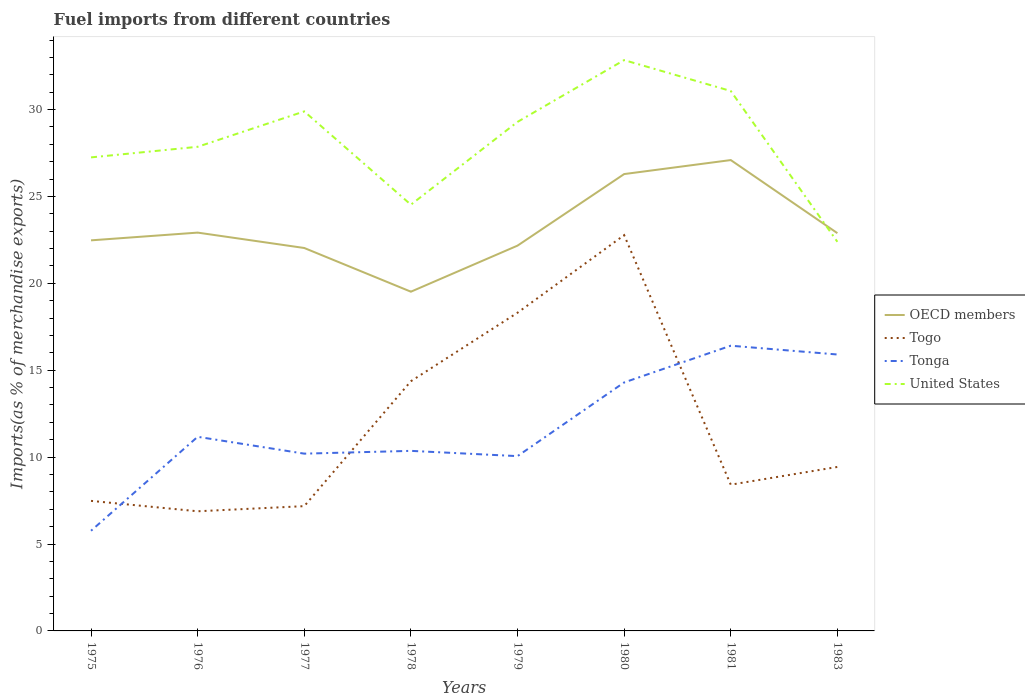How many different coloured lines are there?
Your answer should be very brief. 4. Is the number of lines equal to the number of legend labels?
Provide a succinct answer. Yes. Across all years, what is the maximum percentage of imports to different countries in Tonga?
Keep it short and to the point. 5.76. In which year was the percentage of imports to different countries in Togo maximum?
Make the answer very short. 1976. What is the total percentage of imports to different countries in OECD members in the graph?
Your answer should be compact. -4.25. What is the difference between the highest and the second highest percentage of imports to different countries in Tonga?
Ensure brevity in your answer.  10.65. What is the difference between the highest and the lowest percentage of imports to different countries in OECD members?
Your response must be concise. 2. Does the graph contain grids?
Your response must be concise. No. Where does the legend appear in the graph?
Ensure brevity in your answer.  Center right. How many legend labels are there?
Provide a short and direct response. 4. What is the title of the graph?
Your response must be concise. Fuel imports from different countries. Does "Albania" appear as one of the legend labels in the graph?
Give a very brief answer. No. What is the label or title of the Y-axis?
Keep it short and to the point. Imports(as % of merchandise exports). What is the Imports(as % of merchandise exports) of OECD members in 1975?
Your answer should be compact. 22.47. What is the Imports(as % of merchandise exports) of Togo in 1975?
Ensure brevity in your answer.  7.48. What is the Imports(as % of merchandise exports) of Tonga in 1975?
Your answer should be compact. 5.76. What is the Imports(as % of merchandise exports) of United States in 1975?
Keep it short and to the point. 27.25. What is the Imports(as % of merchandise exports) of OECD members in 1976?
Provide a short and direct response. 22.92. What is the Imports(as % of merchandise exports) in Togo in 1976?
Your answer should be compact. 6.88. What is the Imports(as % of merchandise exports) of Tonga in 1976?
Your answer should be compact. 11.17. What is the Imports(as % of merchandise exports) of United States in 1976?
Keep it short and to the point. 27.86. What is the Imports(as % of merchandise exports) of OECD members in 1977?
Offer a very short reply. 22.03. What is the Imports(as % of merchandise exports) in Togo in 1977?
Offer a terse response. 7.18. What is the Imports(as % of merchandise exports) of Tonga in 1977?
Ensure brevity in your answer.  10.2. What is the Imports(as % of merchandise exports) in United States in 1977?
Your response must be concise. 29.89. What is the Imports(as % of merchandise exports) in OECD members in 1978?
Your response must be concise. 19.52. What is the Imports(as % of merchandise exports) in Togo in 1978?
Provide a succinct answer. 14.37. What is the Imports(as % of merchandise exports) in Tonga in 1978?
Give a very brief answer. 10.36. What is the Imports(as % of merchandise exports) of United States in 1978?
Give a very brief answer. 24.53. What is the Imports(as % of merchandise exports) in OECD members in 1979?
Provide a short and direct response. 22.17. What is the Imports(as % of merchandise exports) in Togo in 1979?
Keep it short and to the point. 18.31. What is the Imports(as % of merchandise exports) of Tonga in 1979?
Your response must be concise. 10.06. What is the Imports(as % of merchandise exports) in United States in 1979?
Your answer should be very brief. 29.29. What is the Imports(as % of merchandise exports) of OECD members in 1980?
Make the answer very short. 26.29. What is the Imports(as % of merchandise exports) in Togo in 1980?
Offer a terse response. 22.77. What is the Imports(as % of merchandise exports) of Tonga in 1980?
Ensure brevity in your answer.  14.3. What is the Imports(as % of merchandise exports) of United States in 1980?
Ensure brevity in your answer.  32.84. What is the Imports(as % of merchandise exports) of OECD members in 1981?
Ensure brevity in your answer.  27.09. What is the Imports(as % of merchandise exports) in Togo in 1981?
Ensure brevity in your answer.  8.41. What is the Imports(as % of merchandise exports) in Tonga in 1981?
Keep it short and to the point. 16.41. What is the Imports(as % of merchandise exports) in United States in 1981?
Offer a terse response. 31.07. What is the Imports(as % of merchandise exports) in OECD members in 1983?
Ensure brevity in your answer.  22.89. What is the Imports(as % of merchandise exports) in Togo in 1983?
Give a very brief answer. 9.44. What is the Imports(as % of merchandise exports) of Tonga in 1983?
Make the answer very short. 15.91. What is the Imports(as % of merchandise exports) in United States in 1983?
Give a very brief answer. 22.39. Across all years, what is the maximum Imports(as % of merchandise exports) of OECD members?
Your answer should be compact. 27.09. Across all years, what is the maximum Imports(as % of merchandise exports) of Togo?
Provide a succinct answer. 22.77. Across all years, what is the maximum Imports(as % of merchandise exports) in Tonga?
Make the answer very short. 16.41. Across all years, what is the maximum Imports(as % of merchandise exports) of United States?
Your answer should be compact. 32.84. Across all years, what is the minimum Imports(as % of merchandise exports) in OECD members?
Keep it short and to the point. 19.52. Across all years, what is the minimum Imports(as % of merchandise exports) in Togo?
Ensure brevity in your answer.  6.88. Across all years, what is the minimum Imports(as % of merchandise exports) of Tonga?
Offer a very short reply. 5.76. Across all years, what is the minimum Imports(as % of merchandise exports) in United States?
Give a very brief answer. 22.39. What is the total Imports(as % of merchandise exports) of OECD members in the graph?
Provide a succinct answer. 185.38. What is the total Imports(as % of merchandise exports) in Togo in the graph?
Your answer should be compact. 94.85. What is the total Imports(as % of merchandise exports) in Tonga in the graph?
Give a very brief answer. 94.17. What is the total Imports(as % of merchandise exports) of United States in the graph?
Provide a short and direct response. 225.12. What is the difference between the Imports(as % of merchandise exports) in OECD members in 1975 and that in 1976?
Provide a short and direct response. -0.44. What is the difference between the Imports(as % of merchandise exports) in Togo in 1975 and that in 1976?
Your answer should be compact. 0.6. What is the difference between the Imports(as % of merchandise exports) of Tonga in 1975 and that in 1976?
Your response must be concise. -5.41. What is the difference between the Imports(as % of merchandise exports) of United States in 1975 and that in 1976?
Offer a very short reply. -0.61. What is the difference between the Imports(as % of merchandise exports) of OECD members in 1975 and that in 1977?
Provide a short and direct response. 0.44. What is the difference between the Imports(as % of merchandise exports) in Togo in 1975 and that in 1977?
Provide a short and direct response. 0.3. What is the difference between the Imports(as % of merchandise exports) in Tonga in 1975 and that in 1977?
Make the answer very short. -4.44. What is the difference between the Imports(as % of merchandise exports) in United States in 1975 and that in 1977?
Your answer should be compact. -2.65. What is the difference between the Imports(as % of merchandise exports) in OECD members in 1975 and that in 1978?
Provide a short and direct response. 2.96. What is the difference between the Imports(as % of merchandise exports) in Togo in 1975 and that in 1978?
Keep it short and to the point. -6.89. What is the difference between the Imports(as % of merchandise exports) in Tonga in 1975 and that in 1978?
Make the answer very short. -4.6. What is the difference between the Imports(as % of merchandise exports) in United States in 1975 and that in 1978?
Your answer should be very brief. 2.72. What is the difference between the Imports(as % of merchandise exports) of OECD members in 1975 and that in 1979?
Provide a succinct answer. 0.3. What is the difference between the Imports(as % of merchandise exports) in Togo in 1975 and that in 1979?
Your response must be concise. -10.83. What is the difference between the Imports(as % of merchandise exports) in Tonga in 1975 and that in 1979?
Offer a terse response. -4.29. What is the difference between the Imports(as % of merchandise exports) in United States in 1975 and that in 1979?
Your answer should be very brief. -2.04. What is the difference between the Imports(as % of merchandise exports) of OECD members in 1975 and that in 1980?
Ensure brevity in your answer.  -3.81. What is the difference between the Imports(as % of merchandise exports) of Togo in 1975 and that in 1980?
Your response must be concise. -15.29. What is the difference between the Imports(as % of merchandise exports) of Tonga in 1975 and that in 1980?
Your answer should be very brief. -8.53. What is the difference between the Imports(as % of merchandise exports) in United States in 1975 and that in 1980?
Offer a terse response. -5.6. What is the difference between the Imports(as % of merchandise exports) of OECD members in 1975 and that in 1981?
Offer a very short reply. -4.62. What is the difference between the Imports(as % of merchandise exports) of Togo in 1975 and that in 1981?
Provide a short and direct response. -0.93. What is the difference between the Imports(as % of merchandise exports) of Tonga in 1975 and that in 1981?
Keep it short and to the point. -10.65. What is the difference between the Imports(as % of merchandise exports) of United States in 1975 and that in 1981?
Ensure brevity in your answer.  -3.82. What is the difference between the Imports(as % of merchandise exports) of OECD members in 1975 and that in 1983?
Give a very brief answer. -0.41. What is the difference between the Imports(as % of merchandise exports) in Togo in 1975 and that in 1983?
Your answer should be compact. -1.95. What is the difference between the Imports(as % of merchandise exports) of Tonga in 1975 and that in 1983?
Keep it short and to the point. -10.14. What is the difference between the Imports(as % of merchandise exports) in United States in 1975 and that in 1983?
Offer a very short reply. 4.86. What is the difference between the Imports(as % of merchandise exports) in OECD members in 1976 and that in 1977?
Provide a succinct answer. 0.89. What is the difference between the Imports(as % of merchandise exports) in Togo in 1976 and that in 1977?
Give a very brief answer. -0.3. What is the difference between the Imports(as % of merchandise exports) of Tonga in 1976 and that in 1977?
Your answer should be compact. 0.97. What is the difference between the Imports(as % of merchandise exports) of United States in 1976 and that in 1977?
Your response must be concise. -2.04. What is the difference between the Imports(as % of merchandise exports) of OECD members in 1976 and that in 1978?
Your response must be concise. 3.4. What is the difference between the Imports(as % of merchandise exports) of Togo in 1976 and that in 1978?
Offer a very short reply. -7.48. What is the difference between the Imports(as % of merchandise exports) of Tonga in 1976 and that in 1978?
Provide a succinct answer. 0.81. What is the difference between the Imports(as % of merchandise exports) of United States in 1976 and that in 1978?
Your answer should be compact. 3.33. What is the difference between the Imports(as % of merchandise exports) of OECD members in 1976 and that in 1979?
Offer a very short reply. 0.75. What is the difference between the Imports(as % of merchandise exports) in Togo in 1976 and that in 1979?
Offer a very short reply. -11.42. What is the difference between the Imports(as % of merchandise exports) in Tonga in 1976 and that in 1979?
Your answer should be very brief. 1.11. What is the difference between the Imports(as % of merchandise exports) of United States in 1976 and that in 1979?
Your answer should be compact. -1.43. What is the difference between the Imports(as % of merchandise exports) in OECD members in 1976 and that in 1980?
Give a very brief answer. -3.37. What is the difference between the Imports(as % of merchandise exports) of Togo in 1976 and that in 1980?
Make the answer very short. -15.89. What is the difference between the Imports(as % of merchandise exports) in Tonga in 1976 and that in 1980?
Provide a short and direct response. -3.13. What is the difference between the Imports(as % of merchandise exports) of United States in 1976 and that in 1980?
Your answer should be very brief. -4.99. What is the difference between the Imports(as % of merchandise exports) in OECD members in 1976 and that in 1981?
Ensure brevity in your answer.  -4.17. What is the difference between the Imports(as % of merchandise exports) in Togo in 1976 and that in 1981?
Provide a succinct answer. -1.53. What is the difference between the Imports(as % of merchandise exports) in Tonga in 1976 and that in 1981?
Ensure brevity in your answer.  -5.24. What is the difference between the Imports(as % of merchandise exports) in United States in 1976 and that in 1981?
Provide a succinct answer. -3.21. What is the difference between the Imports(as % of merchandise exports) of OECD members in 1976 and that in 1983?
Provide a short and direct response. 0.03. What is the difference between the Imports(as % of merchandise exports) of Togo in 1976 and that in 1983?
Offer a terse response. -2.55. What is the difference between the Imports(as % of merchandise exports) of Tonga in 1976 and that in 1983?
Your answer should be very brief. -4.74. What is the difference between the Imports(as % of merchandise exports) of United States in 1976 and that in 1983?
Your answer should be compact. 5.47. What is the difference between the Imports(as % of merchandise exports) in OECD members in 1977 and that in 1978?
Give a very brief answer. 2.51. What is the difference between the Imports(as % of merchandise exports) of Togo in 1977 and that in 1978?
Provide a succinct answer. -7.19. What is the difference between the Imports(as % of merchandise exports) in Tonga in 1977 and that in 1978?
Ensure brevity in your answer.  -0.16. What is the difference between the Imports(as % of merchandise exports) of United States in 1977 and that in 1978?
Keep it short and to the point. 5.37. What is the difference between the Imports(as % of merchandise exports) in OECD members in 1977 and that in 1979?
Provide a short and direct response. -0.14. What is the difference between the Imports(as % of merchandise exports) in Togo in 1977 and that in 1979?
Your answer should be very brief. -11.13. What is the difference between the Imports(as % of merchandise exports) in Tonga in 1977 and that in 1979?
Keep it short and to the point. 0.14. What is the difference between the Imports(as % of merchandise exports) of United States in 1977 and that in 1979?
Keep it short and to the point. 0.6. What is the difference between the Imports(as % of merchandise exports) in OECD members in 1977 and that in 1980?
Provide a succinct answer. -4.25. What is the difference between the Imports(as % of merchandise exports) in Togo in 1977 and that in 1980?
Your answer should be compact. -15.59. What is the difference between the Imports(as % of merchandise exports) in Tonga in 1977 and that in 1980?
Your answer should be compact. -4.1. What is the difference between the Imports(as % of merchandise exports) in United States in 1977 and that in 1980?
Offer a very short reply. -2.95. What is the difference between the Imports(as % of merchandise exports) in OECD members in 1977 and that in 1981?
Your response must be concise. -5.06. What is the difference between the Imports(as % of merchandise exports) of Togo in 1977 and that in 1981?
Provide a short and direct response. -1.23. What is the difference between the Imports(as % of merchandise exports) in Tonga in 1977 and that in 1981?
Provide a short and direct response. -6.21. What is the difference between the Imports(as % of merchandise exports) in United States in 1977 and that in 1981?
Provide a short and direct response. -1.17. What is the difference between the Imports(as % of merchandise exports) of OECD members in 1977 and that in 1983?
Provide a short and direct response. -0.85. What is the difference between the Imports(as % of merchandise exports) of Togo in 1977 and that in 1983?
Offer a very short reply. -2.26. What is the difference between the Imports(as % of merchandise exports) in Tonga in 1977 and that in 1983?
Your answer should be compact. -5.71. What is the difference between the Imports(as % of merchandise exports) of United States in 1977 and that in 1983?
Ensure brevity in your answer.  7.5. What is the difference between the Imports(as % of merchandise exports) of OECD members in 1978 and that in 1979?
Offer a terse response. -2.65. What is the difference between the Imports(as % of merchandise exports) of Togo in 1978 and that in 1979?
Your response must be concise. -3.94. What is the difference between the Imports(as % of merchandise exports) in Tonga in 1978 and that in 1979?
Offer a terse response. 0.3. What is the difference between the Imports(as % of merchandise exports) of United States in 1978 and that in 1979?
Keep it short and to the point. -4.76. What is the difference between the Imports(as % of merchandise exports) in OECD members in 1978 and that in 1980?
Your answer should be very brief. -6.77. What is the difference between the Imports(as % of merchandise exports) in Togo in 1978 and that in 1980?
Give a very brief answer. -8.4. What is the difference between the Imports(as % of merchandise exports) in Tonga in 1978 and that in 1980?
Offer a very short reply. -3.94. What is the difference between the Imports(as % of merchandise exports) in United States in 1978 and that in 1980?
Offer a very short reply. -8.32. What is the difference between the Imports(as % of merchandise exports) in OECD members in 1978 and that in 1981?
Ensure brevity in your answer.  -7.57. What is the difference between the Imports(as % of merchandise exports) in Togo in 1978 and that in 1981?
Provide a short and direct response. 5.95. What is the difference between the Imports(as % of merchandise exports) in Tonga in 1978 and that in 1981?
Make the answer very short. -6.05. What is the difference between the Imports(as % of merchandise exports) of United States in 1978 and that in 1981?
Your answer should be very brief. -6.54. What is the difference between the Imports(as % of merchandise exports) in OECD members in 1978 and that in 1983?
Offer a very short reply. -3.37. What is the difference between the Imports(as % of merchandise exports) of Togo in 1978 and that in 1983?
Ensure brevity in your answer.  4.93. What is the difference between the Imports(as % of merchandise exports) in Tonga in 1978 and that in 1983?
Provide a short and direct response. -5.54. What is the difference between the Imports(as % of merchandise exports) of United States in 1978 and that in 1983?
Ensure brevity in your answer.  2.14. What is the difference between the Imports(as % of merchandise exports) in OECD members in 1979 and that in 1980?
Offer a terse response. -4.12. What is the difference between the Imports(as % of merchandise exports) of Togo in 1979 and that in 1980?
Give a very brief answer. -4.46. What is the difference between the Imports(as % of merchandise exports) of Tonga in 1979 and that in 1980?
Make the answer very short. -4.24. What is the difference between the Imports(as % of merchandise exports) of United States in 1979 and that in 1980?
Give a very brief answer. -3.56. What is the difference between the Imports(as % of merchandise exports) of OECD members in 1979 and that in 1981?
Keep it short and to the point. -4.92. What is the difference between the Imports(as % of merchandise exports) in Togo in 1979 and that in 1981?
Keep it short and to the point. 9.89. What is the difference between the Imports(as % of merchandise exports) in Tonga in 1979 and that in 1981?
Keep it short and to the point. -6.35. What is the difference between the Imports(as % of merchandise exports) in United States in 1979 and that in 1981?
Keep it short and to the point. -1.78. What is the difference between the Imports(as % of merchandise exports) in OECD members in 1979 and that in 1983?
Ensure brevity in your answer.  -0.72. What is the difference between the Imports(as % of merchandise exports) in Togo in 1979 and that in 1983?
Your response must be concise. 8.87. What is the difference between the Imports(as % of merchandise exports) of Tonga in 1979 and that in 1983?
Keep it short and to the point. -5.85. What is the difference between the Imports(as % of merchandise exports) in United States in 1979 and that in 1983?
Offer a terse response. 6.9. What is the difference between the Imports(as % of merchandise exports) in OECD members in 1980 and that in 1981?
Your response must be concise. -0.81. What is the difference between the Imports(as % of merchandise exports) of Togo in 1980 and that in 1981?
Provide a succinct answer. 14.36. What is the difference between the Imports(as % of merchandise exports) of Tonga in 1980 and that in 1981?
Your response must be concise. -2.11. What is the difference between the Imports(as % of merchandise exports) of United States in 1980 and that in 1981?
Your answer should be compact. 1.78. What is the difference between the Imports(as % of merchandise exports) of OECD members in 1980 and that in 1983?
Make the answer very short. 3.4. What is the difference between the Imports(as % of merchandise exports) in Togo in 1980 and that in 1983?
Keep it short and to the point. 13.34. What is the difference between the Imports(as % of merchandise exports) in Tonga in 1980 and that in 1983?
Your answer should be very brief. -1.61. What is the difference between the Imports(as % of merchandise exports) of United States in 1980 and that in 1983?
Keep it short and to the point. 10.45. What is the difference between the Imports(as % of merchandise exports) in OECD members in 1981 and that in 1983?
Your answer should be very brief. 4.21. What is the difference between the Imports(as % of merchandise exports) in Togo in 1981 and that in 1983?
Make the answer very short. -1.02. What is the difference between the Imports(as % of merchandise exports) of Tonga in 1981 and that in 1983?
Keep it short and to the point. 0.51. What is the difference between the Imports(as % of merchandise exports) in United States in 1981 and that in 1983?
Make the answer very short. 8.68. What is the difference between the Imports(as % of merchandise exports) of OECD members in 1975 and the Imports(as % of merchandise exports) of Togo in 1976?
Offer a very short reply. 15.59. What is the difference between the Imports(as % of merchandise exports) in OECD members in 1975 and the Imports(as % of merchandise exports) in Tonga in 1976?
Make the answer very short. 11.3. What is the difference between the Imports(as % of merchandise exports) in OECD members in 1975 and the Imports(as % of merchandise exports) in United States in 1976?
Your answer should be very brief. -5.38. What is the difference between the Imports(as % of merchandise exports) of Togo in 1975 and the Imports(as % of merchandise exports) of Tonga in 1976?
Your answer should be very brief. -3.69. What is the difference between the Imports(as % of merchandise exports) of Togo in 1975 and the Imports(as % of merchandise exports) of United States in 1976?
Offer a very short reply. -20.37. What is the difference between the Imports(as % of merchandise exports) of Tonga in 1975 and the Imports(as % of merchandise exports) of United States in 1976?
Your answer should be compact. -22.09. What is the difference between the Imports(as % of merchandise exports) of OECD members in 1975 and the Imports(as % of merchandise exports) of Togo in 1977?
Your answer should be compact. 15.29. What is the difference between the Imports(as % of merchandise exports) in OECD members in 1975 and the Imports(as % of merchandise exports) in Tonga in 1977?
Ensure brevity in your answer.  12.27. What is the difference between the Imports(as % of merchandise exports) in OECD members in 1975 and the Imports(as % of merchandise exports) in United States in 1977?
Provide a short and direct response. -7.42. What is the difference between the Imports(as % of merchandise exports) in Togo in 1975 and the Imports(as % of merchandise exports) in Tonga in 1977?
Give a very brief answer. -2.72. What is the difference between the Imports(as % of merchandise exports) in Togo in 1975 and the Imports(as % of merchandise exports) in United States in 1977?
Provide a short and direct response. -22.41. What is the difference between the Imports(as % of merchandise exports) in Tonga in 1975 and the Imports(as % of merchandise exports) in United States in 1977?
Provide a short and direct response. -24.13. What is the difference between the Imports(as % of merchandise exports) of OECD members in 1975 and the Imports(as % of merchandise exports) of Togo in 1978?
Offer a terse response. 8.11. What is the difference between the Imports(as % of merchandise exports) in OECD members in 1975 and the Imports(as % of merchandise exports) in Tonga in 1978?
Your response must be concise. 12.11. What is the difference between the Imports(as % of merchandise exports) of OECD members in 1975 and the Imports(as % of merchandise exports) of United States in 1978?
Make the answer very short. -2.05. What is the difference between the Imports(as % of merchandise exports) of Togo in 1975 and the Imports(as % of merchandise exports) of Tonga in 1978?
Give a very brief answer. -2.88. What is the difference between the Imports(as % of merchandise exports) in Togo in 1975 and the Imports(as % of merchandise exports) in United States in 1978?
Your answer should be very brief. -17.04. What is the difference between the Imports(as % of merchandise exports) of Tonga in 1975 and the Imports(as % of merchandise exports) of United States in 1978?
Offer a terse response. -18.76. What is the difference between the Imports(as % of merchandise exports) in OECD members in 1975 and the Imports(as % of merchandise exports) in Togo in 1979?
Offer a very short reply. 4.17. What is the difference between the Imports(as % of merchandise exports) in OECD members in 1975 and the Imports(as % of merchandise exports) in Tonga in 1979?
Offer a very short reply. 12.42. What is the difference between the Imports(as % of merchandise exports) in OECD members in 1975 and the Imports(as % of merchandise exports) in United States in 1979?
Provide a succinct answer. -6.82. What is the difference between the Imports(as % of merchandise exports) of Togo in 1975 and the Imports(as % of merchandise exports) of Tonga in 1979?
Give a very brief answer. -2.58. What is the difference between the Imports(as % of merchandise exports) in Togo in 1975 and the Imports(as % of merchandise exports) in United States in 1979?
Your response must be concise. -21.81. What is the difference between the Imports(as % of merchandise exports) of Tonga in 1975 and the Imports(as % of merchandise exports) of United States in 1979?
Provide a succinct answer. -23.53. What is the difference between the Imports(as % of merchandise exports) in OECD members in 1975 and the Imports(as % of merchandise exports) in Togo in 1980?
Your response must be concise. -0.3. What is the difference between the Imports(as % of merchandise exports) of OECD members in 1975 and the Imports(as % of merchandise exports) of Tonga in 1980?
Your answer should be compact. 8.18. What is the difference between the Imports(as % of merchandise exports) in OECD members in 1975 and the Imports(as % of merchandise exports) in United States in 1980?
Offer a terse response. -10.37. What is the difference between the Imports(as % of merchandise exports) in Togo in 1975 and the Imports(as % of merchandise exports) in Tonga in 1980?
Provide a short and direct response. -6.81. What is the difference between the Imports(as % of merchandise exports) in Togo in 1975 and the Imports(as % of merchandise exports) in United States in 1980?
Make the answer very short. -25.36. What is the difference between the Imports(as % of merchandise exports) in Tonga in 1975 and the Imports(as % of merchandise exports) in United States in 1980?
Make the answer very short. -27.08. What is the difference between the Imports(as % of merchandise exports) of OECD members in 1975 and the Imports(as % of merchandise exports) of Togo in 1981?
Your answer should be very brief. 14.06. What is the difference between the Imports(as % of merchandise exports) of OECD members in 1975 and the Imports(as % of merchandise exports) of Tonga in 1981?
Provide a short and direct response. 6.06. What is the difference between the Imports(as % of merchandise exports) in OECD members in 1975 and the Imports(as % of merchandise exports) in United States in 1981?
Provide a short and direct response. -8.59. What is the difference between the Imports(as % of merchandise exports) in Togo in 1975 and the Imports(as % of merchandise exports) in Tonga in 1981?
Ensure brevity in your answer.  -8.93. What is the difference between the Imports(as % of merchandise exports) of Togo in 1975 and the Imports(as % of merchandise exports) of United States in 1981?
Your response must be concise. -23.59. What is the difference between the Imports(as % of merchandise exports) in Tonga in 1975 and the Imports(as % of merchandise exports) in United States in 1981?
Provide a short and direct response. -25.3. What is the difference between the Imports(as % of merchandise exports) of OECD members in 1975 and the Imports(as % of merchandise exports) of Togo in 1983?
Provide a short and direct response. 13.04. What is the difference between the Imports(as % of merchandise exports) in OECD members in 1975 and the Imports(as % of merchandise exports) in Tonga in 1983?
Keep it short and to the point. 6.57. What is the difference between the Imports(as % of merchandise exports) in OECD members in 1975 and the Imports(as % of merchandise exports) in United States in 1983?
Make the answer very short. 0.08. What is the difference between the Imports(as % of merchandise exports) of Togo in 1975 and the Imports(as % of merchandise exports) of Tonga in 1983?
Offer a very short reply. -8.42. What is the difference between the Imports(as % of merchandise exports) of Togo in 1975 and the Imports(as % of merchandise exports) of United States in 1983?
Give a very brief answer. -14.91. What is the difference between the Imports(as % of merchandise exports) in Tonga in 1975 and the Imports(as % of merchandise exports) in United States in 1983?
Keep it short and to the point. -16.63. What is the difference between the Imports(as % of merchandise exports) of OECD members in 1976 and the Imports(as % of merchandise exports) of Togo in 1977?
Keep it short and to the point. 15.74. What is the difference between the Imports(as % of merchandise exports) of OECD members in 1976 and the Imports(as % of merchandise exports) of Tonga in 1977?
Your response must be concise. 12.72. What is the difference between the Imports(as % of merchandise exports) in OECD members in 1976 and the Imports(as % of merchandise exports) in United States in 1977?
Your response must be concise. -6.97. What is the difference between the Imports(as % of merchandise exports) of Togo in 1976 and the Imports(as % of merchandise exports) of Tonga in 1977?
Keep it short and to the point. -3.32. What is the difference between the Imports(as % of merchandise exports) of Togo in 1976 and the Imports(as % of merchandise exports) of United States in 1977?
Your answer should be compact. -23.01. What is the difference between the Imports(as % of merchandise exports) of Tonga in 1976 and the Imports(as % of merchandise exports) of United States in 1977?
Your answer should be compact. -18.72. What is the difference between the Imports(as % of merchandise exports) of OECD members in 1976 and the Imports(as % of merchandise exports) of Togo in 1978?
Give a very brief answer. 8.55. What is the difference between the Imports(as % of merchandise exports) in OECD members in 1976 and the Imports(as % of merchandise exports) in Tonga in 1978?
Offer a very short reply. 12.56. What is the difference between the Imports(as % of merchandise exports) in OECD members in 1976 and the Imports(as % of merchandise exports) in United States in 1978?
Your answer should be very brief. -1.61. What is the difference between the Imports(as % of merchandise exports) in Togo in 1976 and the Imports(as % of merchandise exports) in Tonga in 1978?
Provide a succinct answer. -3.48. What is the difference between the Imports(as % of merchandise exports) in Togo in 1976 and the Imports(as % of merchandise exports) in United States in 1978?
Ensure brevity in your answer.  -17.64. What is the difference between the Imports(as % of merchandise exports) of Tonga in 1976 and the Imports(as % of merchandise exports) of United States in 1978?
Your answer should be very brief. -13.36. What is the difference between the Imports(as % of merchandise exports) in OECD members in 1976 and the Imports(as % of merchandise exports) in Togo in 1979?
Your answer should be very brief. 4.61. What is the difference between the Imports(as % of merchandise exports) of OECD members in 1976 and the Imports(as % of merchandise exports) of Tonga in 1979?
Offer a very short reply. 12.86. What is the difference between the Imports(as % of merchandise exports) in OECD members in 1976 and the Imports(as % of merchandise exports) in United States in 1979?
Keep it short and to the point. -6.37. What is the difference between the Imports(as % of merchandise exports) of Togo in 1976 and the Imports(as % of merchandise exports) of Tonga in 1979?
Your answer should be very brief. -3.17. What is the difference between the Imports(as % of merchandise exports) of Togo in 1976 and the Imports(as % of merchandise exports) of United States in 1979?
Provide a short and direct response. -22.41. What is the difference between the Imports(as % of merchandise exports) in Tonga in 1976 and the Imports(as % of merchandise exports) in United States in 1979?
Offer a terse response. -18.12. What is the difference between the Imports(as % of merchandise exports) of OECD members in 1976 and the Imports(as % of merchandise exports) of Togo in 1980?
Your answer should be very brief. 0.15. What is the difference between the Imports(as % of merchandise exports) in OECD members in 1976 and the Imports(as % of merchandise exports) in Tonga in 1980?
Offer a very short reply. 8.62. What is the difference between the Imports(as % of merchandise exports) of OECD members in 1976 and the Imports(as % of merchandise exports) of United States in 1980?
Provide a succinct answer. -9.93. What is the difference between the Imports(as % of merchandise exports) of Togo in 1976 and the Imports(as % of merchandise exports) of Tonga in 1980?
Keep it short and to the point. -7.41. What is the difference between the Imports(as % of merchandise exports) of Togo in 1976 and the Imports(as % of merchandise exports) of United States in 1980?
Provide a succinct answer. -25.96. What is the difference between the Imports(as % of merchandise exports) in Tonga in 1976 and the Imports(as % of merchandise exports) in United States in 1980?
Offer a terse response. -21.67. What is the difference between the Imports(as % of merchandise exports) of OECD members in 1976 and the Imports(as % of merchandise exports) of Togo in 1981?
Give a very brief answer. 14.5. What is the difference between the Imports(as % of merchandise exports) in OECD members in 1976 and the Imports(as % of merchandise exports) in Tonga in 1981?
Make the answer very short. 6.51. What is the difference between the Imports(as % of merchandise exports) in OECD members in 1976 and the Imports(as % of merchandise exports) in United States in 1981?
Your answer should be very brief. -8.15. What is the difference between the Imports(as % of merchandise exports) in Togo in 1976 and the Imports(as % of merchandise exports) in Tonga in 1981?
Provide a succinct answer. -9.53. What is the difference between the Imports(as % of merchandise exports) in Togo in 1976 and the Imports(as % of merchandise exports) in United States in 1981?
Make the answer very short. -24.18. What is the difference between the Imports(as % of merchandise exports) of Tonga in 1976 and the Imports(as % of merchandise exports) of United States in 1981?
Your answer should be very brief. -19.9. What is the difference between the Imports(as % of merchandise exports) in OECD members in 1976 and the Imports(as % of merchandise exports) in Togo in 1983?
Offer a terse response. 13.48. What is the difference between the Imports(as % of merchandise exports) in OECD members in 1976 and the Imports(as % of merchandise exports) in Tonga in 1983?
Offer a very short reply. 7.01. What is the difference between the Imports(as % of merchandise exports) in OECD members in 1976 and the Imports(as % of merchandise exports) in United States in 1983?
Make the answer very short. 0.53. What is the difference between the Imports(as % of merchandise exports) of Togo in 1976 and the Imports(as % of merchandise exports) of Tonga in 1983?
Your answer should be compact. -9.02. What is the difference between the Imports(as % of merchandise exports) in Togo in 1976 and the Imports(as % of merchandise exports) in United States in 1983?
Give a very brief answer. -15.51. What is the difference between the Imports(as % of merchandise exports) in Tonga in 1976 and the Imports(as % of merchandise exports) in United States in 1983?
Give a very brief answer. -11.22. What is the difference between the Imports(as % of merchandise exports) in OECD members in 1977 and the Imports(as % of merchandise exports) in Togo in 1978?
Offer a terse response. 7.67. What is the difference between the Imports(as % of merchandise exports) in OECD members in 1977 and the Imports(as % of merchandise exports) in Tonga in 1978?
Your answer should be very brief. 11.67. What is the difference between the Imports(as % of merchandise exports) in OECD members in 1977 and the Imports(as % of merchandise exports) in United States in 1978?
Keep it short and to the point. -2.49. What is the difference between the Imports(as % of merchandise exports) of Togo in 1977 and the Imports(as % of merchandise exports) of Tonga in 1978?
Provide a succinct answer. -3.18. What is the difference between the Imports(as % of merchandise exports) in Togo in 1977 and the Imports(as % of merchandise exports) in United States in 1978?
Provide a succinct answer. -17.35. What is the difference between the Imports(as % of merchandise exports) of Tonga in 1977 and the Imports(as % of merchandise exports) of United States in 1978?
Your answer should be compact. -14.33. What is the difference between the Imports(as % of merchandise exports) in OECD members in 1977 and the Imports(as % of merchandise exports) in Togo in 1979?
Provide a succinct answer. 3.72. What is the difference between the Imports(as % of merchandise exports) of OECD members in 1977 and the Imports(as % of merchandise exports) of Tonga in 1979?
Make the answer very short. 11.98. What is the difference between the Imports(as % of merchandise exports) in OECD members in 1977 and the Imports(as % of merchandise exports) in United States in 1979?
Your response must be concise. -7.26. What is the difference between the Imports(as % of merchandise exports) of Togo in 1977 and the Imports(as % of merchandise exports) of Tonga in 1979?
Ensure brevity in your answer.  -2.88. What is the difference between the Imports(as % of merchandise exports) of Togo in 1977 and the Imports(as % of merchandise exports) of United States in 1979?
Offer a terse response. -22.11. What is the difference between the Imports(as % of merchandise exports) in Tonga in 1977 and the Imports(as % of merchandise exports) in United States in 1979?
Keep it short and to the point. -19.09. What is the difference between the Imports(as % of merchandise exports) in OECD members in 1977 and the Imports(as % of merchandise exports) in Togo in 1980?
Your answer should be very brief. -0.74. What is the difference between the Imports(as % of merchandise exports) of OECD members in 1977 and the Imports(as % of merchandise exports) of Tonga in 1980?
Give a very brief answer. 7.74. What is the difference between the Imports(as % of merchandise exports) in OECD members in 1977 and the Imports(as % of merchandise exports) in United States in 1980?
Your response must be concise. -10.81. What is the difference between the Imports(as % of merchandise exports) in Togo in 1977 and the Imports(as % of merchandise exports) in Tonga in 1980?
Your response must be concise. -7.12. What is the difference between the Imports(as % of merchandise exports) of Togo in 1977 and the Imports(as % of merchandise exports) of United States in 1980?
Your answer should be compact. -25.66. What is the difference between the Imports(as % of merchandise exports) in Tonga in 1977 and the Imports(as % of merchandise exports) in United States in 1980?
Offer a very short reply. -22.64. What is the difference between the Imports(as % of merchandise exports) of OECD members in 1977 and the Imports(as % of merchandise exports) of Togo in 1981?
Make the answer very short. 13.62. What is the difference between the Imports(as % of merchandise exports) in OECD members in 1977 and the Imports(as % of merchandise exports) in Tonga in 1981?
Provide a succinct answer. 5.62. What is the difference between the Imports(as % of merchandise exports) of OECD members in 1977 and the Imports(as % of merchandise exports) of United States in 1981?
Your answer should be compact. -9.03. What is the difference between the Imports(as % of merchandise exports) in Togo in 1977 and the Imports(as % of merchandise exports) in Tonga in 1981?
Offer a terse response. -9.23. What is the difference between the Imports(as % of merchandise exports) in Togo in 1977 and the Imports(as % of merchandise exports) in United States in 1981?
Keep it short and to the point. -23.89. What is the difference between the Imports(as % of merchandise exports) in Tonga in 1977 and the Imports(as % of merchandise exports) in United States in 1981?
Provide a short and direct response. -20.87. What is the difference between the Imports(as % of merchandise exports) of OECD members in 1977 and the Imports(as % of merchandise exports) of Togo in 1983?
Offer a very short reply. 12.6. What is the difference between the Imports(as % of merchandise exports) of OECD members in 1977 and the Imports(as % of merchandise exports) of Tonga in 1983?
Offer a very short reply. 6.13. What is the difference between the Imports(as % of merchandise exports) in OECD members in 1977 and the Imports(as % of merchandise exports) in United States in 1983?
Keep it short and to the point. -0.36. What is the difference between the Imports(as % of merchandise exports) in Togo in 1977 and the Imports(as % of merchandise exports) in Tonga in 1983?
Give a very brief answer. -8.73. What is the difference between the Imports(as % of merchandise exports) of Togo in 1977 and the Imports(as % of merchandise exports) of United States in 1983?
Keep it short and to the point. -15.21. What is the difference between the Imports(as % of merchandise exports) of Tonga in 1977 and the Imports(as % of merchandise exports) of United States in 1983?
Ensure brevity in your answer.  -12.19. What is the difference between the Imports(as % of merchandise exports) of OECD members in 1978 and the Imports(as % of merchandise exports) of Togo in 1979?
Make the answer very short. 1.21. What is the difference between the Imports(as % of merchandise exports) in OECD members in 1978 and the Imports(as % of merchandise exports) in Tonga in 1979?
Provide a short and direct response. 9.46. What is the difference between the Imports(as % of merchandise exports) of OECD members in 1978 and the Imports(as % of merchandise exports) of United States in 1979?
Your response must be concise. -9.77. What is the difference between the Imports(as % of merchandise exports) of Togo in 1978 and the Imports(as % of merchandise exports) of Tonga in 1979?
Make the answer very short. 4.31. What is the difference between the Imports(as % of merchandise exports) of Togo in 1978 and the Imports(as % of merchandise exports) of United States in 1979?
Make the answer very short. -14.92. What is the difference between the Imports(as % of merchandise exports) in Tonga in 1978 and the Imports(as % of merchandise exports) in United States in 1979?
Offer a terse response. -18.93. What is the difference between the Imports(as % of merchandise exports) in OECD members in 1978 and the Imports(as % of merchandise exports) in Togo in 1980?
Keep it short and to the point. -3.25. What is the difference between the Imports(as % of merchandise exports) in OECD members in 1978 and the Imports(as % of merchandise exports) in Tonga in 1980?
Your answer should be compact. 5.22. What is the difference between the Imports(as % of merchandise exports) of OECD members in 1978 and the Imports(as % of merchandise exports) of United States in 1980?
Your answer should be compact. -13.33. What is the difference between the Imports(as % of merchandise exports) of Togo in 1978 and the Imports(as % of merchandise exports) of Tonga in 1980?
Your answer should be very brief. 0.07. What is the difference between the Imports(as % of merchandise exports) in Togo in 1978 and the Imports(as % of merchandise exports) in United States in 1980?
Your response must be concise. -18.48. What is the difference between the Imports(as % of merchandise exports) of Tonga in 1978 and the Imports(as % of merchandise exports) of United States in 1980?
Your response must be concise. -22.48. What is the difference between the Imports(as % of merchandise exports) of OECD members in 1978 and the Imports(as % of merchandise exports) of Togo in 1981?
Give a very brief answer. 11.1. What is the difference between the Imports(as % of merchandise exports) in OECD members in 1978 and the Imports(as % of merchandise exports) in Tonga in 1981?
Your answer should be compact. 3.11. What is the difference between the Imports(as % of merchandise exports) of OECD members in 1978 and the Imports(as % of merchandise exports) of United States in 1981?
Ensure brevity in your answer.  -11.55. What is the difference between the Imports(as % of merchandise exports) of Togo in 1978 and the Imports(as % of merchandise exports) of Tonga in 1981?
Offer a very short reply. -2.04. What is the difference between the Imports(as % of merchandise exports) of Togo in 1978 and the Imports(as % of merchandise exports) of United States in 1981?
Your answer should be compact. -16.7. What is the difference between the Imports(as % of merchandise exports) in Tonga in 1978 and the Imports(as % of merchandise exports) in United States in 1981?
Offer a terse response. -20.71. What is the difference between the Imports(as % of merchandise exports) of OECD members in 1978 and the Imports(as % of merchandise exports) of Togo in 1983?
Offer a very short reply. 10.08. What is the difference between the Imports(as % of merchandise exports) of OECD members in 1978 and the Imports(as % of merchandise exports) of Tonga in 1983?
Ensure brevity in your answer.  3.61. What is the difference between the Imports(as % of merchandise exports) of OECD members in 1978 and the Imports(as % of merchandise exports) of United States in 1983?
Your answer should be compact. -2.87. What is the difference between the Imports(as % of merchandise exports) of Togo in 1978 and the Imports(as % of merchandise exports) of Tonga in 1983?
Your answer should be compact. -1.54. What is the difference between the Imports(as % of merchandise exports) of Togo in 1978 and the Imports(as % of merchandise exports) of United States in 1983?
Keep it short and to the point. -8.02. What is the difference between the Imports(as % of merchandise exports) in Tonga in 1978 and the Imports(as % of merchandise exports) in United States in 1983?
Your response must be concise. -12.03. What is the difference between the Imports(as % of merchandise exports) of OECD members in 1979 and the Imports(as % of merchandise exports) of Togo in 1980?
Your response must be concise. -0.6. What is the difference between the Imports(as % of merchandise exports) of OECD members in 1979 and the Imports(as % of merchandise exports) of Tonga in 1980?
Your answer should be compact. 7.87. What is the difference between the Imports(as % of merchandise exports) of OECD members in 1979 and the Imports(as % of merchandise exports) of United States in 1980?
Your response must be concise. -10.68. What is the difference between the Imports(as % of merchandise exports) in Togo in 1979 and the Imports(as % of merchandise exports) in Tonga in 1980?
Give a very brief answer. 4.01. What is the difference between the Imports(as % of merchandise exports) in Togo in 1979 and the Imports(as % of merchandise exports) in United States in 1980?
Offer a very short reply. -14.54. What is the difference between the Imports(as % of merchandise exports) in Tonga in 1979 and the Imports(as % of merchandise exports) in United States in 1980?
Your answer should be compact. -22.79. What is the difference between the Imports(as % of merchandise exports) of OECD members in 1979 and the Imports(as % of merchandise exports) of Togo in 1981?
Your answer should be compact. 13.75. What is the difference between the Imports(as % of merchandise exports) in OECD members in 1979 and the Imports(as % of merchandise exports) in Tonga in 1981?
Provide a succinct answer. 5.76. What is the difference between the Imports(as % of merchandise exports) in OECD members in 1979 and the Imports(as % of merchandise exports) in United States in 1981?
Provide a short and direct response. -8.9. What is the difference between the Imports(as % of merchandise exports) in Togo in 1979 and the Imports(as % of merchandise exports) in Tonga in 1981?
Offer a terse response. 1.9. What is the difference between the Imports(as % of merchandise exports) in Togo in 1979 and the Imports(as % of merchandise exports) in United States in 1981?
Offer a terse response. -12.76. What is the difference between the Imports(as % of merchandise exports) of Tonga in 1979 and the Imports(as % of merchandise exports) of United States in 1981?
Your response must be concise. -21.01. What is the difference between the Imports(as % of merchandise exports) in OECD members in 1979 and the Imports(as % of merchandise exports) in Togo in 1983?
Offer a terse response. 12.73. What is the difference between the Imports(as % of merchandise exports) of OECD members in 1979 and the Imports(as % of merchandise exports) of Tonga in 1983?
Ensure brevity in your answer.  6.26. What is the difference between the Imports(as % of merchandise exports) in OECD members in 1979 and the Imports(as % of merchandise exports) in United States in 1983?
Ensure brevity in your answer.  -0.22. What is the difference between the Imports(as % of merchandise exports) in Togo in 1979 and the Imports(as % of merchandise exports) in Tonga in 1983?
Your answer should be very brief. 2.4. What is the difference between the Imports(as % of merchandise exports) of Togo in 1979 and the Imports(as % of merchandise exports) of United States in 1983?
Provide a short and direct response. -4.08. What is the difference between the Imports(as % of merchandise exports) of Tonga in 1979 and the Imports(as % of merchandise exports) of United States in 1983?
Give a very brief answer. -12.33. What is the difference between the Imports(as % of merchandise exports) of OECD members in 1980 and the Imports(as % of merchandise exports) of Togo in 1981?
Provide a short and direct response. 17.87. What is the difference between the Imports(as % of merchandise exports) of OECD members in 1980 and the Imports(as % of merchandise exports) of Tonga in 1981?
Provide a succinct answer. 9.88. What is the difference between the Imports(as % of merchandise exports) in OECD members in 1980 and the Imports(as % of merchandise exports) in United States in 1981?
Your response must be concise. -4.78. What is the difference between the Imports(as % of merchandise exports) of Togo in 1980 and the Imports(as % of merchandise exports) of Tonga in 1981?
Provide a succinct answer. 6.36. What is the difference between the Imports(as % of merchandise exports) of Togo in 1980 and the Imports(as % of merchandise exports) of United States in 1981?
Make the answer very short. -8.29. What is the difference between the Imports(as % of merchandise exports) of Tonga in 1980 and the Imports(as % of merchandise exports) of United States in 1981?
Provide a short and direct response. -16.77. What is the difference between the Imports(as % of merchandise exports) in OECD members in 1980 and the Imports(as % of merchandise exports) in Togo in 1983?
Keep it short and to the point. 16.85. What is the difference between the Imports(as % of merchandise exports) of OECD members in 1980 and the Imports(as % of merchandise exports) of Tonga in 1983?
Your response must be concise. 10.38. What is the difference between the Imports(as % of merchandise exports) in OECD members in 1980 and the Imports(as % of merchandise exports) in United States in 1983?
Give a very brief answer. 3.9. What is the difference between the Imports(as % of merchandise exports) of Togo in 1980 and the Imports(as % of merchandise exports) of Tonga in 1983?
Keep it short and to the point. 6.87. What is the difference between the Imports(as % of merchandise exports) of Togo in 1980 and the Imports(as % of merchandise exports) of United States in 1983?
Your answer should be very brief. 0.38. What is the difference between the Imports(as % of merchandise exports) in Tonga in 1980 and the Imports(as % of merchandise exports) in United States in 1983?
Provide a succinct answer. -8.09. What is the difference between the Imports(as % of merchandise exports) in OECD members in 1981 and the Imports(as % of merchandise exports) in Togo in 1983?
Your answer should be compact. 17.66. What is the difference between the Imports(as % of merchandise exports) of OECD members in 1981 and the Imports(as % of merchandise exports) of Tonga in 1983?
Your response must be concise. 11.19. What is the difference between the Imports(as % of merchandise exports) of OECD members in 1981 and the Imports(as % of merchandise exports) of United States in 1983?
Provide a succinct answer. 4.7. What is the difference between the Imports(as % of merchandise exports) of Togo in 1981 and the Imports(as % of merchandise exports) of Tonga in 1983?
Your answer should be compact. -7.49. What is the difference between the Imports(as % of merchandise exports) in Togo in 1981 and the Imports(as % of merchandise exports) in United States in 1983?
Your answer should be compact. -13.98. What is the difference between the Imports(as % of merchandise exports) in Tonga in 1981 and the Imports(as % of merchandise exports) in United States in 1983?
Keep it short and to the point. -5.98. What is the average Imports(as % of merchandise exports) of OECD members per year?
Offer a very short reply. 23.17. What is the average Imports(as % of merchandise exports) in Togo per year?
Make the answer very short. 11.86. What is the average Imports(as % of merchandise exports) of Tonga per year?
Give a very brief answer. 11.77. What is the average Imports(as % of merchandise exports) of United States per year?
Provide a short and direct response. 28.14. In the year 1975, what is the difference between the Imports(as % of merchandise exports) in OECD members and Imports(as % of merchandise exports) in Togo?
Your answer should be compact. 14.99. In the year 1975, what is the difference between the Imports(as % of merchandise exports) of OECD members and Imports(as % of merchandise exports) of Tonga?
Make the answer very short. 16.71. In the year 1975, what is the difference between the Imports(as % of merchandise exports) of OECD members and Imports(as % of merchandise exports) of United States?
Offer a terse response. -4.77. In the year 1975, what is the difference between the Imports(as % of merchandise exports) of Togo and Imports(as % of merchandise exports) of Tonga?
Give a very brief answer. 1.72. In the year 1975, what is the difference between the Imports(as % of merchandise exports) of Togo and Imports(as % of merchandise exports) of United States?
Provide a short and direct response. -19.77. In the year 1975, what is the difference between the Imports(as % of merchandise exports) of Tonga and Imports(as % of merchandise exports) of United States?
Provide a short and direct response. -21.48. In the year 1976, what is the difference between the Imports(as % of merchandise exports) in OECD members and Imports(as % of merchandise exports) in Togo?
Provide a succinct answer. 16.03. In the year 1976, what is the difference between the Imports(as % of merchandise exports) of OECD members and Imports(as % of merchandise exports) of Tonga?
Offer a very short reply. 11.75. In the year 1976, what is the difference between the Imports(as % of merchandise exports) of OECD members and Imports(as % of merchandise exports) of United States?
Make the answer very short. -4.94. In the year 1976, what is the difference between the Imports(as % of merchandise exports) in Togo and Imports(as % of merchandise exports) in Tonga?
Offer a terse response. -4.29. In the year 1976, what is the difference between the Imports(as % of merchandise exports) in Togo and Imports(as % of merchandise exports) in United States?
Ensure brevity in your answer.  -20.97. In the year 1976, what is the difference between the Imports(as % of merchandise exports) in Tonga and Imports(as % of merchandise exports) in United States?
Offer a very short reply. -16.69. In the year 1977, what is the difference between the Imports(as % of merchandise exports) of OECD members and Imports(as % of merchandise exports) of Togo?
Keep it short and to the point. 14.85. In the year 1977, what is the difference between the Imports(as % of merchandise exports) of OECD members and Imports(as % of merchandise exports) of Tonga?
Your answer should be very brief. 11.83. In the year 1977, what is the difference between the Imports(as % of merchandise exports) in OECD members and Imports(as % of merchandise exports) in United States?
Ensure brevity in your answer.  -7.86. In the year 1977, what is the difference between the Imports(as % of merchandise exports) of Togo and Imports(as % of merchandise exports) of Tonga?
Provide a succinct answer. -3.02. In the year 1977, what is the difference between the Imports(as % of merchandise exports) in Togo and Imports(as % of merchandise exports) in United States?
Your response must be concise. -22.71. In the year 1977, what is the difference between the Imports(as % of merchandise exports) in Tonga and Imports(as % of merchandise exports) in United States?
Provide a short and direct response. -19.69. In the year 1978, what is the difference between the Imports(as % of merchandise exports) of OECD members and Imports(as % of merchandise exports) of Togo?
Your answer should be very brief. 5.15. In the year 1978, what is the difference between the Imports(as % of merchandise exports) of OECD members and Imports(as % of merchandise exports) of Tonga?
Offer a very short reply. 9.16. In the year 1978, what is the difference between the Imports(as % of merchandise exports) in OECD members and Imports(as % of merchandise exports) in United States?
Make the answer very short. -5.01. In the year 1978, what is the difference between the Imports(as % of merchandise exports) of Togo and Imports(as % of merchandise exports) of Tonga?
Your response must be concise. 4.01. In the year 1978, what is the difference between the Imports(as % of merchandise exports) of Togo and Imports(as % of merchandise exports) of United States?
Provide a succinct answer. -10.16. In the year 1978, what is the difference between the Imports(as % of merchandise exports) of Tonga and Imports(as % of merchandise exports) of United States?
Offer a terse response. -14.17. In the year 1979, what is the difference between the Imports(as % of merchandise exports) of OECD members and Imports(as % of merchandise exports) of Togo?
Offer a very short reply. 3.86. In the year 1979, what is the difference between the Imports(as % of merchandise exports) of OECD members and Imports(as % of merchandise exports) of Tonga?
Your answer should be very brief. 12.11. In the year 1979, what is the difference between the Imports(as % of merchandise exports) of OECD members and Imports(as % of merchandise exports) of United States?
Give a very brief answer. -7.12. In the year 1979, what is the difference between the Imports(as % of merchandise exports) in Togo and Imports(as % of merchandise exports) in Tonga?
Your response must be concise. 8.25. In the year 1979, what is the difference between the Imports(as % of merchandise exports) in Togo and Imports(as % of merchandise exports) in United States?
Offer a terse response. -10.98. In the year 1979, what is the difference between the Imports(as % of merchandise exports) of Tonga and Imports(as % of merchandise exports) of United States?
Provide a short and direct response. -19.23. In the year 1980, what is the difference between the Imports(as % of merchandise exports) of OECD members and Imports(as % of merchandise exports) of Togo?
Your answer should be compact. 3.51. In the year 1980, what is the difference between the Imports(as % of merchandise exports) of OECD members and Imports(as % of merchandise exports) of Tonga?
Your answer should be very brief. 11.99. In the year 1980, what is the difference between the Imports(as % of merchandise exports) of OECD members and Imports(as % of merchandise exports) of United States?
Ensure brevity in your answer.  -6.56. In the year 1980, what is the difference between the Imports(as % of merchandise exports) in Togo and Imports(as % of merchandise exports) in Tonga?
Offer a terse response. 8.48. In the year 1980, what is the difference between the Imports(as % of merchandise exports) of Togo and Imports(as % of merchandise exports) of United States?
Give a very brief answer. -10.07. In the year 1980, what is the difference between the Imports(as % of merchandise exports) of Tonga and Imports(as % of merchandise exports) of United States?
Give a very brief answer. -18.55. In the year 1981, what is the difference between the Imports(as % of merchandise exports) of OECD members and Imports(as % of merchandise exports) of Togo?
Your answer should be compact. 18.68. In the year 1981, what is the difference between the Imports(as % of merchandise exports) in OECD members and Imports(as % of merchandise exports) in Tonga?
Make the answer very short. 10.68. In the year 1981, what is the difference between the Imports(as % of merchandise exports) in OECD members and Imports(as % of merchandise exports) in United States?
Keep it short and to the point. -3.97. In the year 1981, what is the difference between the Imports(as % of merchandise exports) in Togo and Imports(as % of merchandise exports) in Tonga?
Give a very brief answer. -8. In the year 1981, what is the difference between the Imports(as % of merchandise exports) of Togo and Imports(as % of merchandise exports) of United States?
Provide a succinct answer. -22.65. In the year 1981, what is the difference between the Imports(as % of merchandise exports) in Tonga and Imports(as % of merchandise exports) in United States?
Keep it short and to the point. -14.66. In the year 1983, what is the difference between the Imports(as % of merchandise exports) of OECD members and Imports(as % of merchandise exports) of Togo?
Keep it short and to the point. 13.45. In the year 1983, what is the difference between the Imports(as % of merchandise exports) in OECD members and Imports(as % of merchandise exports) in Tonga?
Your answer should be very brief. 6.98. In the year 1983, what is the difference between the Imports(as % of merchandise exports) in OECD members and Imports(as % of merchandise exports) in United States?
Make the answer very short. 0.5. In the year 1983, what is the difference between the Imports(as % of merchandise exports) of Togo and Imports(as % of merchandise exports) of Tonga?
Your answer should be very brief. -6.47. In the year 1983, what is the difference between the Imports(as % of merchandise exports) in Togo and Imports(as % of merchandise exports) in United States?
Your response must be concise. -12.95. In the year 1983, what is the difference between the Imports(as % of merchandise exports) of Tonga and Imports(as % of merchandise exports) of United States?
Your response must be concise. -6.48. What is the ratio of the Imports(as % of merchandise exports) in OECD members in 1975 to that in 1976?
Your response must be concise. 0.98. What is the ratio of the Imports(as % of merchandise exports) of Togo in 1975 to that in 1976?
Give a very brief answer. 1.09. What is the ratio of the Imports(as % of merchandise exports) in Tonga in 1975 to that in 1976?
Keep it short and to the point. 0.52. What is the ratio of the Imports(as % of merchandise exports) of United States in 1975 to that in 1976?
Your response must be concise. 0.98. What is the ratio of the Imports(as % of merchandise exports) in OECD members in 1975 to that in 1977?
Make the answer very short. 1.02. What is the ratio of the Imports(as % of merchandise exports) in Togo in 1975 to that in 1977?
Offer a very short reply. 1.04. What is the ratio of the Imports(as % of merchandise exports) in Tonga in 1975 to that in 1977?
Your response must be concise. 0.56. What is the ratio of the Imports(as % of merchandise exports) of United States in 1975 to that in 1977?
Keep it short and to the point. 0.91. What is the ratio of the Imports(as % of merchandise exports) of OECD members in 1975 to that in 1978?
Your answer should be very brief. 1.15. What is the ratio of the Imports(as % of merchandise exports) of Togo in 1975 to that in 1978?
Provide a succinct answer. 0.52. What is the ratio of the Imports(as % of merchandise exports) of Tonga in 1975 to that in 1978?
Give a very brief answer. 0.56. What is the ratio of the Imports(as % of merchandise exports) in United States in 1975 to that in 1978?
Your answer should be very brief. 1.11. What is the ratio of the Imports(as % of merchandise exports) in OECD members in 1975 to that in 1979?
Offer a very short reply. 1.01. What is the ratio of the Imports(as % of merchandise exports) in Togo in 1975 to that in 1979?
Your response must be concise. 0.41. What is the ratio of the Imports(as % of merchandise exports) in Tonga in 1975 to that in 1979?
Provide a succinct answer. 0.57. What is the ratio of the Imports(as % of merchandise exports) in United States in 1975 to that in 1979?
Offer a very short reply. 0.93. What is the ratio of the Imports(as % of merchandise exports) of OECD members in 1975 to that in 1980?
Your answer should be very brief. 0.85. What is the ratio of the Imports(as % of merchandise exports) of Togo in 1975 to that in 1980?
Keep it short and to the point. 0.33. What is the ratio of the Imports(as % of merchandise exports) in Tonga in 1975 to that in 1980?
Offer a terse response. 0.4. What is the ratio of the Imports(as % of merchandise exports) of United States in 1975 to that in 1980?
Offer a very short reply. 0.83. What is the ratio of the Imports(as % of merchandise exports) in OECD members in 1975 to that in 1981?
Provide a succinct answer. 0.83. What is the ratio of the Imports(as % of merchandise exports) in Togo in 1975 to that in 1981?
Provide a short and direct response. 0.89. What is the ratio of the Imports(as % of merchandise exports) of Tonga in 1975 to that in 1981?
Make the answer very short. 0.35. What is the ratio of the Imports(as % of merchandise exports) in United States in 1975 to that in 1981?
Provide a short and direct response. 0.88. What is the ratio of the Imports(as % of merchandise exports) in OECD members in 1975 to that in 1983?
Provide a short and direct response. 0.98. What is the ratio of the Imports(as % of merchandise exports) of Togo in 1975 to that in 1983?
Offer a very short reply. 0.79. What is the ratio of the Imports(as % of merchandise exports) in Tonga in 1975 to that in 1983?
Your answer should be very brief. 0.36. What is the ratio of the Imports(as % of merchandise exports) in United States in 1975 to that in 1983?
Your answer should be compact. 1.22. What is the ratio of the Imports(as % of merchandise exports) in OECD members in 1976 to that in 1977?
Your response must be concise. 1.04. What is the ratio of the Imports(as % of merchandise exports) in Togo in 1976 to that in 1977?
Keep it short and to the point. 0.96. What is the ratio of the Imports(as % of merchandise exports) of Tonga in 1976 to that in 1977?
Make the answer very short. 1.1. What is the ratio of the Imports(as % of merchandise exports) in United States in 1976 to that in 1977?
Offer a very short reply. 0.93. What is the ratio of the Imports(as % of merchandise exports) of OECD members in 1976 to that in 1978?
Your response must be concise. 1.17. What is the ratio of the Imports(as % of merchandise exports) of Togo in 1976 to that in 1978?
Your answer should be compact. 0.48. What is the ratio of the Imports(as % of merchandise exports) in Tonga in 1976 to that in 1978?
Provide a short and direct response. 1.08. What is the ratio of the Imports(as % of merchandise exports) in United States in 1976 to that in 1978?
Make the answer very short. 1.14. What is the ratio of the Imports(as % of merchandise exports) of OECD members in 1976 to that in 1979?
Make the answer very short. 1.03. What is the ratio of the Imports(as % of merchandise exports) of Togo in 1976 to that in 1979?
Your response must be concise. 0.38. What is the ratio of the Imports(as % of merchandise exports) of Tonga in 1976 to that in 1979?
Provide a succinct answer. 1.11. What is the ratio of the Imports(as % of merchandise exports) in United States in 1976 to that in 1979?
Give a very brief answer. 0.95. What is the ratio of the Imports(as % of merchandise exports) in OECD members in 1976 to that in 1980?
Your answer should be compact. 0.87. What is the ratio of the Imports(as % of merchandise exports) in Togo in 1976 to that in 1980?
Keep it short and to the point. 0.3. What is the ratio of the Imports(as % of merchandise exports) of Tonga in 1976 to that in 1980?
Provide a short and direct response. 0.78. What is the ratio of the Imports(as % of merchandise exports) of United States in 1976 to that in 1980?
Your answer should be very brief. 0.85. What is the ratio of the Imports(as % of merchandise exports) in OECD members in 1976 to that in 1981?
Your answer should be compact. 0.85. What is the ratio of the Imports(as % of merchandise exports) in Togo in 1976 to that in 1981?
Provide a short and direct response. 0.82. What is the ratio of the Imports(as % of merchandise exports) in Tonga in 1976 to that in 1981?
Your answer should be very brief. 0.68. What is the ratio of the Imports(as % of merchandise exports) in United States in 1976 to that in 1981?
Your answer should be compact. 0.9. What is the ratio of the Imports(as % of merchandise exports) of Togo in 1976 to that in 1983?
Make the answer very short. 0.73. What is the ratio of the Imports(as % of merchandise exports) of Tonga in 1976 to that in 1983?
Offer a terse response. 0.7. What is the ratio of the Imports(as % of merchandise exports) in United States in 1976 to that in 1983?
Your answer should be compact. 1.24. What is the ratio of the Imports(as % of merchandise exports) in OECD members in 1977 to that in 1978?
Make the answer very short. 1.13. What is the ratio of the Imports(as % of merchandise exports) of Togo in 1977 to that in 1978?
Give a very brief answer. 0.5. What is the ratio of the Imports(as % of merchandise exports) in Tonga in 1977 to that in 1978?
Offer a very short reply. 0.98. What is the ratio of the Imports(as % of merchandise exports) in United States in 1977 to that in 1978?
Give a very brief answer. 1.22. What is the ratio of the Imports(as % of merchandise exports) of Togo in 1977 to that in 1979?
Offer a very short reply. 0.39. What is the ratio of the Imports(as % of merchandise exports) in Tonga in 1977 to that in 1979?
Provide a short and direct response. 1.01. What is the ratio of the Imports(as % of merchandise exports) in United States in 1977 to that in 1979?
Your response must be concise. 1.02. What is the ratio of the Imports(as % of merchandise exports) of OECD members in 1977 to that in 1980?
Make the answer very short. 0.84. What is the ratio of the Imports(as % of merchandise exports) of Togo in 1977 to that in 1980?
Provide a short and direct response. 0.32. What is the ratio of the Imports(as % of merchandise exports) in Tonga in 1977 to that in 1980?
Your answer should be compact. 0.71. What is the ratio of the Imports(as % of merchandise exports) in United States in 1977 to that in 1980?
Your answer should be very brief. 0.91. What is the ratio of the Imports(as % of merchandise exports) of OECD members in 1977 to that in 1981?
Your answer should be compact. 0.81. What is the ratio of the Imports(as % of merchandise exports) in Togo in 1977 to that in 1981?
Provide a short and direct response. 0.85. What is the ratio of the Imports(as % of merchandise exports) of Tonga in 1977 to that in 1981?
Provide a short and direct response. 0.62. What is the ratio of the Imports(as % of merchandise exports) in United States in 1977 to that in 1981?
Your answer should be compact. 0.96. What is the ratio of the Imports(as % of merchandise exports) of OECD members in 1977 to that in 1983?
Your answer should be compact. 0.96. What is the ratio of the Imports(as % of merchandise exports) of Togo in 1977 to that in 1983?
Offer a very short reply. 0.76. What is the ratio of the Imports(as % of merchandise exports) of Tonga in 1977 to that in 1983?
Offer a terse response. 0.64. What is the ratio of the Imports(as % of merchandise exports) in United States in 1977 to that in 1983?
Keep it short and to the point. 1.34. What is the ratio of the Imports(as % of merchandise exports) in OECD members in 1978 to that in 1979?
Make the answer very short. 0.88. What is the ratio of the Imports(as % of merchandise exports) of Togo in 1978 to that in 1979?
Give a very brief answer. 0.78. What is the ratio of the Imports(as % of merchandise exports) of Tonga in 1978 to that in 1979?
Give a very brief answer. 1.03. What is the ratio of the Imports(as % of merchandise exports) of United States in 1978 to that in 1979?
Ensure brevity in your answer.  0.84. What is the ratio of the Imports(as % of merchandise exports) of OECD members in 1978 to that in 1980?
Offer a terse response. 0.74. What is the ratio of the Imports(as % of merchandise exports) of Togo in 1978 to that in 1980?
Your answer should be compact. 0.63. What is the ratio of the Imports(as % of merchandise exports) of Tonga in 1978 to that in 1980?
Your answer should be very brief. 0.72. What is the ratio of the Imports(as % of merchandise exports) of United States in 1978 to that in 1980?
Provide a short and direct response. 0.75. What is the ratio of the Imports(as % of merchandise exports) in OECD members in 1978 to that in 1981?
Provide a succinct answer. 0.72. What is the ratio of the Imports(as % of merchandise exports) in Togo in 1978 to that in 1981?
Provide a succinct answer. 1.71. What is the ratio of the Imports(as % of merchandise exports) in Tonga in 1978 to that in 1981?
Ensure brevity in your answer.  0.63. What is the ratio of the Imports(as % of merchandise exports) in United States in 1978 to that in 1981?
Ensure brevity in your answer.  0.79. What is the ratio of the Imports(as % of merchandise exports) of OECD members in 1978 to that in 1983?
Keep it short and to the point. 0.85. What is the ratio of the Imports(as % of merchandise exports) of Togo in 1978 to that in 1983?
Your answer should be very brief. 1.52. What is the ratio of the Imports(as % of merchandise exports) of Tonga in 1978 to that in 1983?
Offer a terse response. 0.65. What is the ratio of the Imports(as % of merchandise exports) in United States in 1978 to that in 1983?
Offer a very short reply. 1.1. What is the ratio of the Imports(as % of merchandise exports) in OECD members in 1979 to that in 1980?
Offer a very short reply. 0.84. What is the ratio of the Imports(as % of merchandise exports) of Togo in 1979 to that in 1980?
Give a very brief answer. 0.8. What is the ratio of the Imports(as % of merchandise exports) of Tonga in 1979 to that in 1980?
Ensure brevity in your answer.  0.7. What is the ratio of the Imports(as % of merchandise exports) of United States in 1979 to that in 1980?
Make the answer very short. 0.89. What is the ratio of the Imports(as % of merchandise exports) of OECD members in 1979 to that in 1981?
Provide a succinct answer. 0.82. What is the ratio of the Imports(as % of merchandise exports) in Togo in 1979 to that in 1981?
Provide a succinct answer. 2.18. What is the ratio of the Imports(as % of merchandise exports) in Tonga in 1979 to that in 1981?
Keep it short and to the point. 0.61. What is the ratio of the Imports(as % of merchandise exports) in United States in 1979 to that in 1981?
Keep it short and to the point. 0.94. What is the ratio of the Imports(as % of merchandise exports) in OECD members in 1979 to that in 1983?
Offer a terse response. 0.97. What is the ratio of the Imports(as % of merchandise exports) in Togo in 1979 to that in 1983?
Your answer should be compact. 1.94. What is the ratio of the Imports(as % of merchandise exports) in Tonga in 1979 to that in 1983?
Make the answer very short. 0.63. What is the ratio of the Imports(as % of merchandise exports) of United States in 1979 to that in 1983?
Your answer should be compact. 1.31. What is the ratio of the Imports(as % of merchandise exports) of OECD members in 1980 to that in 1981?
Offer a terse response. 0.97. What is the ratio of the Imports(as % of merchandise exports) in Togo in 1980 to that in 1981?
Provide a succinct answer. 2.71. What is the ratio of the Imports(as % of merchandise exports) in Tonga in 1980 to that in 1981?
Your answer should be very brief. 0.87. What is the ratio of the Imports(as % of merchandise exports) in United States in 1980 to that in 1981?
Ensure brevity in your answer.  1.06. What is the ratio of the Imports(as % of merchandise exports) in OECD members in 1980 to that in 1983?
Make the answer very short. 1.15. What is the ratio of the Imports(as % of merchandise exports) in Togo in 1980 to that in 1983?
Your answer should be very brief. 2.41. What is the ratio of the Imports(as % of merchandise exports) in Tonga in 1980 to that in 1983?
Keep it short and to the point. 0.9. What is the ratio of the Imports(as % of merchandise exports) in United States in 1980 to that in 1983?
Keep it short and to the point. 1.47. What is the ratio of the Imports(as % of merchandise exports) of OECD members in 1981 to that in 1983?
Ensure brevity in your answer.  1.18. What is the ratio of the Imports(as % of merchandise exports) in Togo in 1981 to that in 1983?
Offer a terse response. 0.89. What is the ratio of the Imports(as % of merchandise exports) of Tonga in 1981 to that in 1983?
Provide a succinct answer. 1.03. What is the ratio of the Imports(as % of merchandise exports) of United States in 1981 to that in 1983?
Offer a terse response. 1.39. What is the difference between the highest and the second highest Imports(as % of merchandise exports) of OECD members?
Keep it short and to the point. 0.81. What is the difference between the highest and the second highest Imports(as % of merchandise exports) of Togo?
Offer a terse response. 4.46. What is the difference between the highest and the second highest Imports(as % of merchandise exports) of Tonga?
Offer a very short reply. 0.51. What is the difference between the highest and the second highest Imports(as % of merchandise exports) in United States?
Give a very brief answer. 1.78. What is the difference between the highest and the lowest Imports(as % of merchandise exports) of OECD members?
Your answer should be very brief. 7.57. What is the difference between the highest and the lowest Imports(as % of merchandise exports) of Togo?
Make the answer very short. 15.89. What is the difference between the highest and the lowest Imports(as % of merchandise exports) of Tonga?
Offer a very short reply. 10.65. What is the difference between the highest and the lowest Imports(as % of merchandise exports) in United States?
Give a very brief answer. 10.45. 